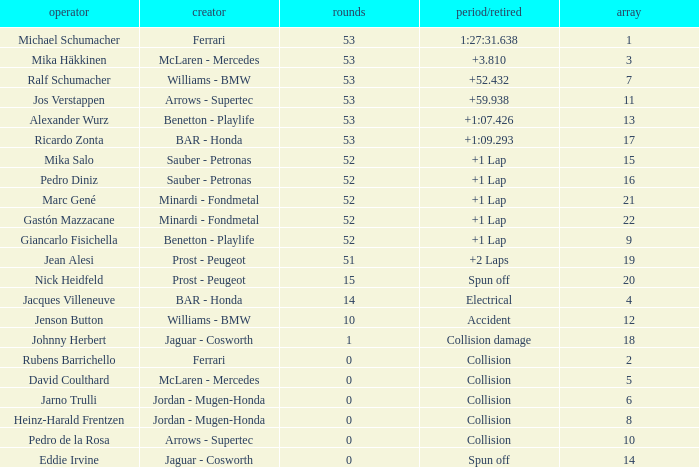How many laps did Ricardo Zonta have? 53.0. 